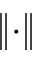Convert formula to latex. <formula><loc_0><loc_0><loc_500><loc_500>\| \cdot \|</formula> 